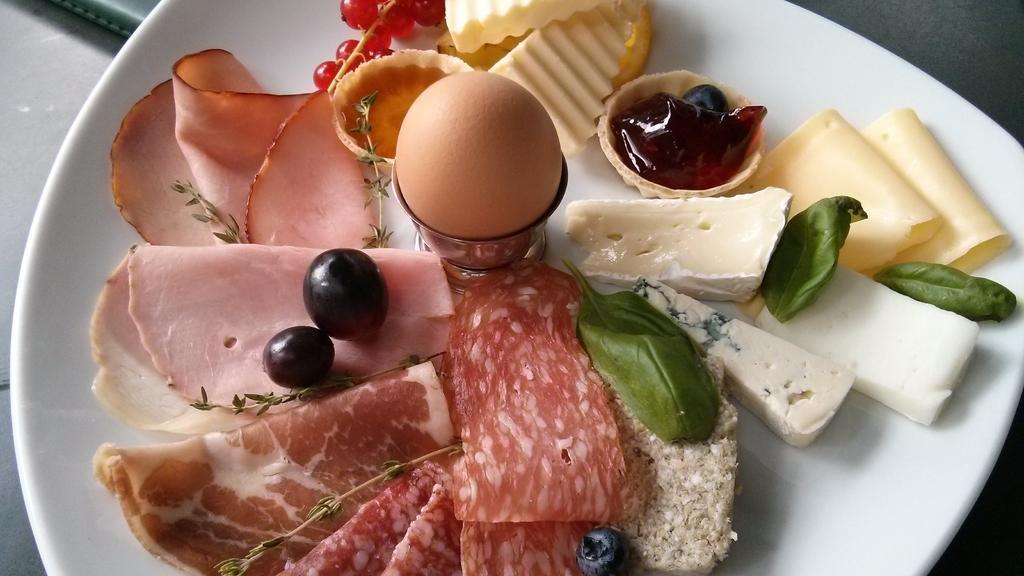Please provide a concise description of this image. This image contains a plate which is kept on the table. On the plate there is some fruits, leafy vegetables and some food are on it. 